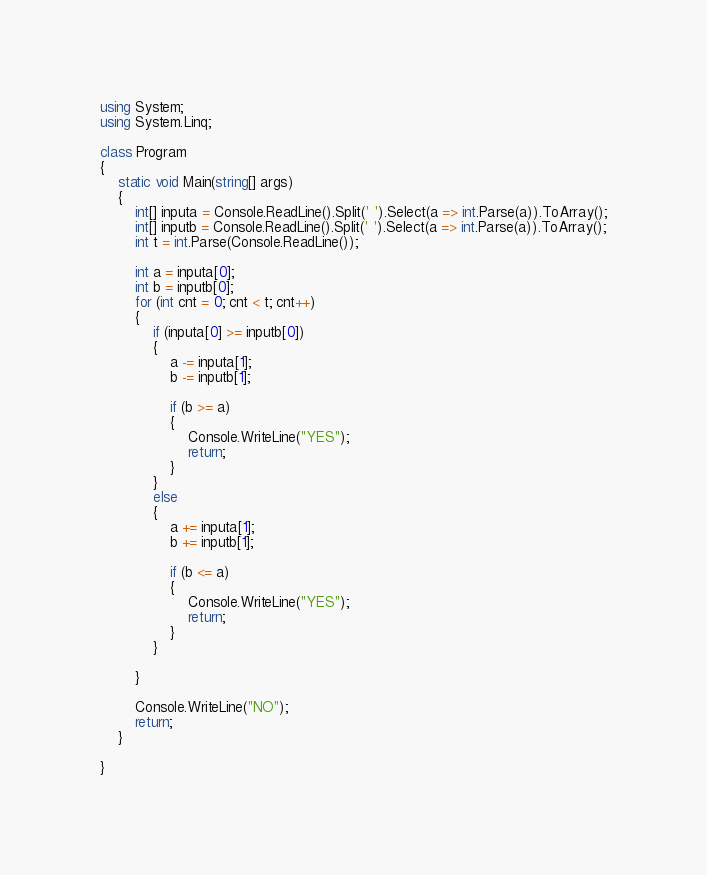<code> <loc_0><loc_0><loc_500><loc_500><_C#_>using System;
using System.Linq;

class Program
{
    static void Main(string[] args)
    {
        int[] inputa = Console.ReadLine().Split(' ').Select(a => int.Parse(a)).ToArray();
        int[] inputb = Console.ReadLine().Split(' ').Select(a => int.Parse(a)).ToArray();
        int t = int.Parse(Console.ReadLine());

        int a = inputa[0];
        int b = inputb[0];
        for (int cnt = 0; cnt < t; cnt++)
        {
            if (inputa[0] >= inputb[0])
            {
                a -= inputa[1];
                b -= inputb[1];

                if (b >= a)
                {
                    Console.WriteLine("YES");
                    return;
                }
            }
            else
            {
                a += inputa[1];
                b += inputb[1];

                if (b <= a)
                {
                    Console.WriteLine("YES");
                    return;
                }
            }

        }

        Console.WriteLine("NO");
        return;
    }

}


</code> 